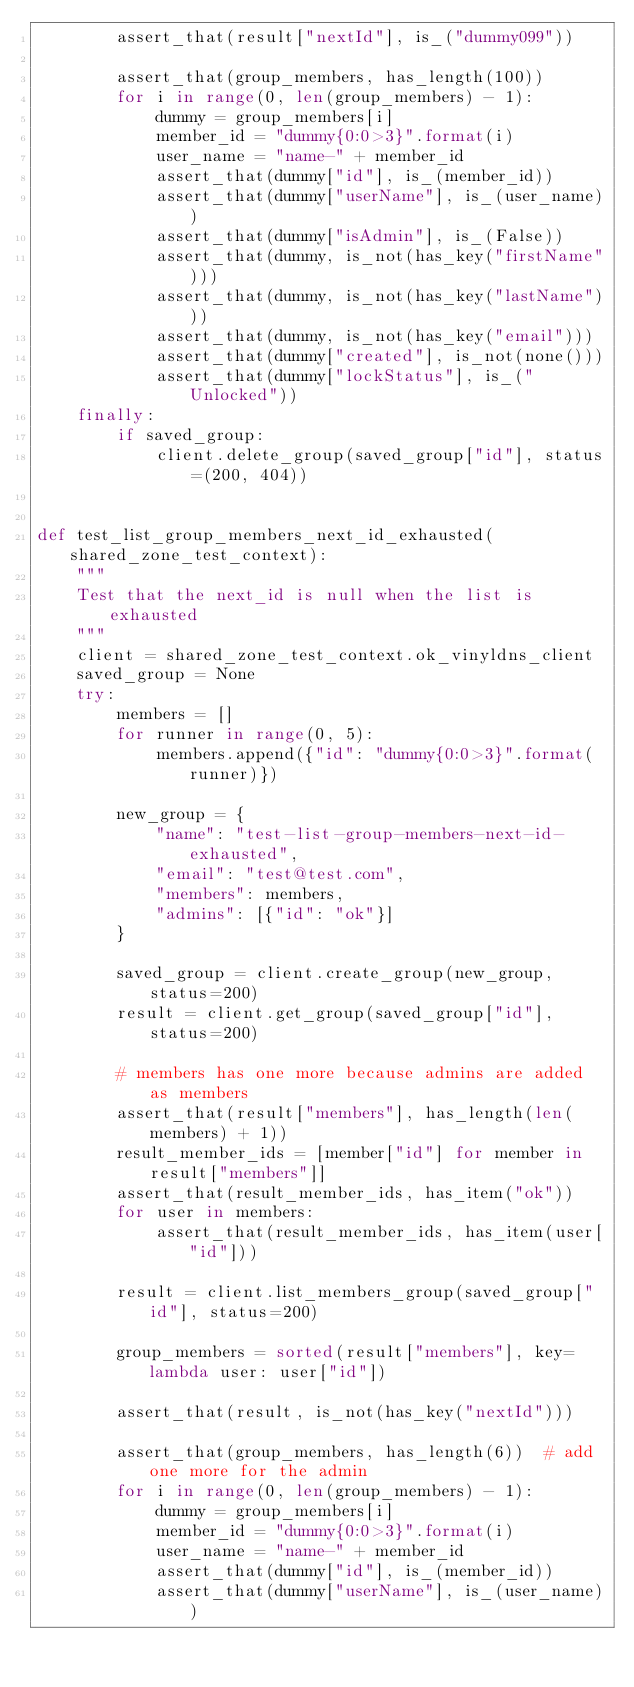<code> <loc_0><loc_0><loc_500><loc_500><_Python_>        assert_that(result["nextId"], is_("dummy099"))

        assert_that(group_members, has_length(100))
        for i in range(0, len(group_members) - 1):
            dummy = group_members[i]
            member_id = "dummy{0:0>3}".format(i)
            user_name = "name-" + member_id
            assert_that(dummy["id"], is_(member_id))
            assert_that(dummy["userName"], is_(user_name))
            assert_that(dummy["isAdmin"], is_(False))
            assert_that(dummy, is_not(has_key("firstName")))
            assert_that(dummy, is_not(has_key("lastName")))
            assert_that(dummy, is_not(has_key("email")))
            assert_that(dummy["created"], is_not(none()))
            assert_that(dummy["lockStatus"], is_("Unlocked"))
    finally:
        if saved_group:
            client.delete_group(saved_group["id"], status=(200, 404))


def test_list_group_members_next_id_exhausted(shared_zone_test_context):
    """
    Test that the next_id is null when the list is exhausted
    """
    client = shared_zone_test_context.ok_vinyldns_client
    saved_group = None
    try:
        members = []
        for runner in range(0, 5):
            members.append({"id": "dummy{0:0>3}".format(runner)})

        new_group = {
            "name": "test-list-group-members-next-id-exhausted",
            "email": "test@test.com",
            "members": members,
            "admins": [{"id": "ok"}]
        }

        saved_group = client.create_group(new_group, status=200)
        result = client.get_group(saved_group["id"], status=200)

        # members has one more because admins are added as members
        assert_that(result["members"], has_length(len(members) + 1))
        result_member_ids = [member["id"] for member in result["members"]]
        assert_that(result_member_ids, has_item("ok"))
        for user in members:
            assert_that(result_member_ids, has_item(user["id"]))

        result = client.list_members_group(saved_group["id"], status=200)

        group_members = sorted(result["members"], key=lambda user: user["id"])

        assert_that(result, is_not(has_key("nextId")))

        assert_that(group_members, has_length(6))  # add one more for the admin
        for i in range(0, len(group_members) - 1):
            dummy = group_members[i]
            member_id = "dummy{0:0>3}".format(i)
            user_name = "name-" + member_id
            assert_that(dummy["id"], is_(member_id))
            assert_that(dummy["userName"], is_(user_name))</code> 